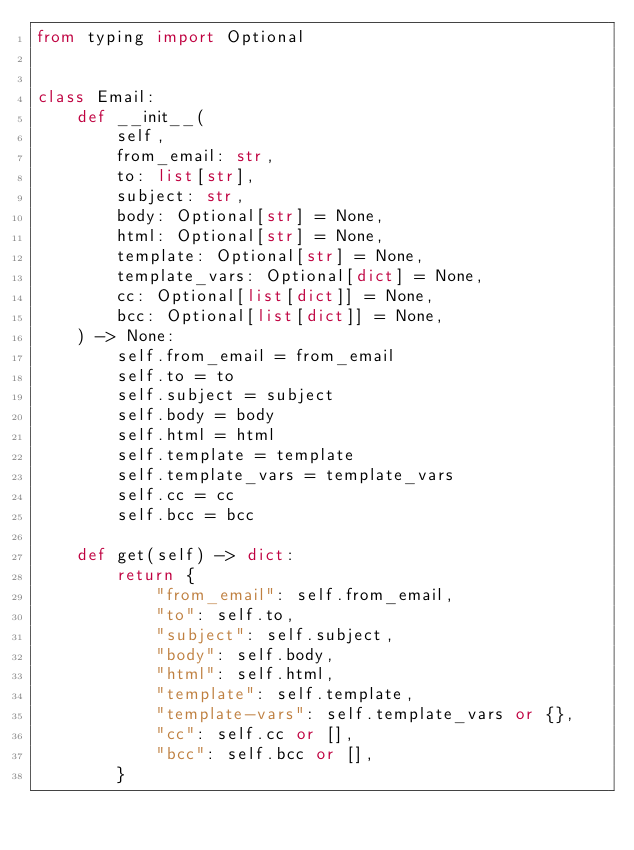Convert code to text. <code><loc_0><loc_0><loc_500><loc_500><_Python_>from typing import Optional


class Email:
    def __init__(
        self,
        from_email: str,
        to: list[str],
        subject: str,
        body: Optional[str] = None,
        html: Optional[str] = None,
        template: Optional[str] = None,
        template_vars: Optional[dict] = None,
        cc: Optional[list[dict]] = None,
        bcc: Optional[list[dict]] = None,
    ) -> None:
        self.from_email = from_email
        self.to = to
        self.subject = subject
        self.body = body
        self.html = html
        self.template = template
        self.template_vars = template_vars
        self.cc = cc
        self.bcc = bcc

    def get(self) -> dict:
        return {
            "from_email": self.from_email,
            "to": self.to,
            "subject": self.subject,
            "body": self.body,
            "html": self.html,
            "template": self.template,
            "template-vars": self.template_vars or {},
            "cc": self.cc or [],
            "bcc": self.bcc or [],
        }
</code> 